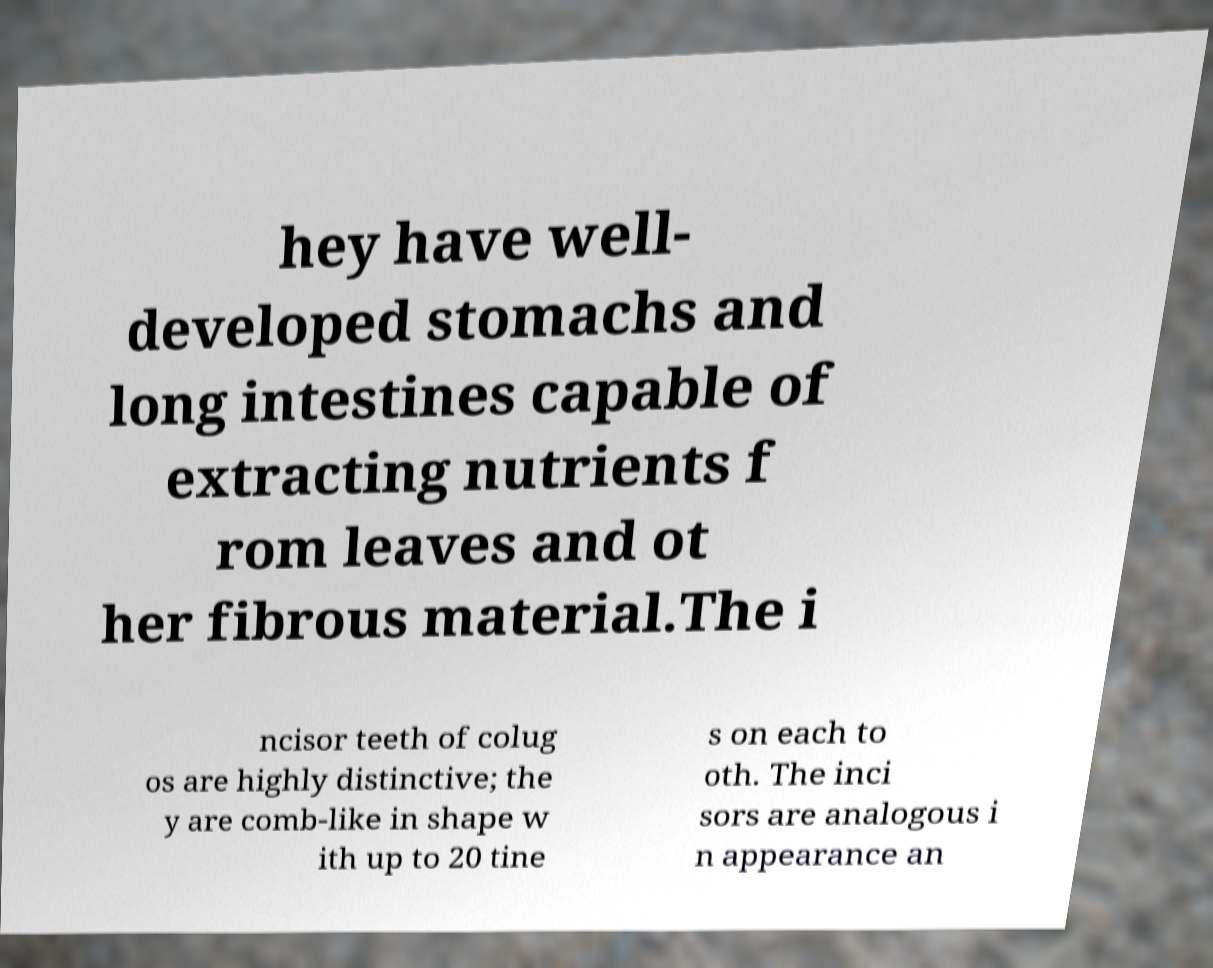For documentation purposes, I need the text within this image transcribed. Could you provide that? hey have well- developed stomachs and long intestines capable of extracting nutrients f rom leaves and ot her fibrous material.The i ncisor teeth of colug os are highly distinctive; the y are comb-like in shape w ith up to 20 tine s on each to oth. The inci sors are analogous i n appearance an 